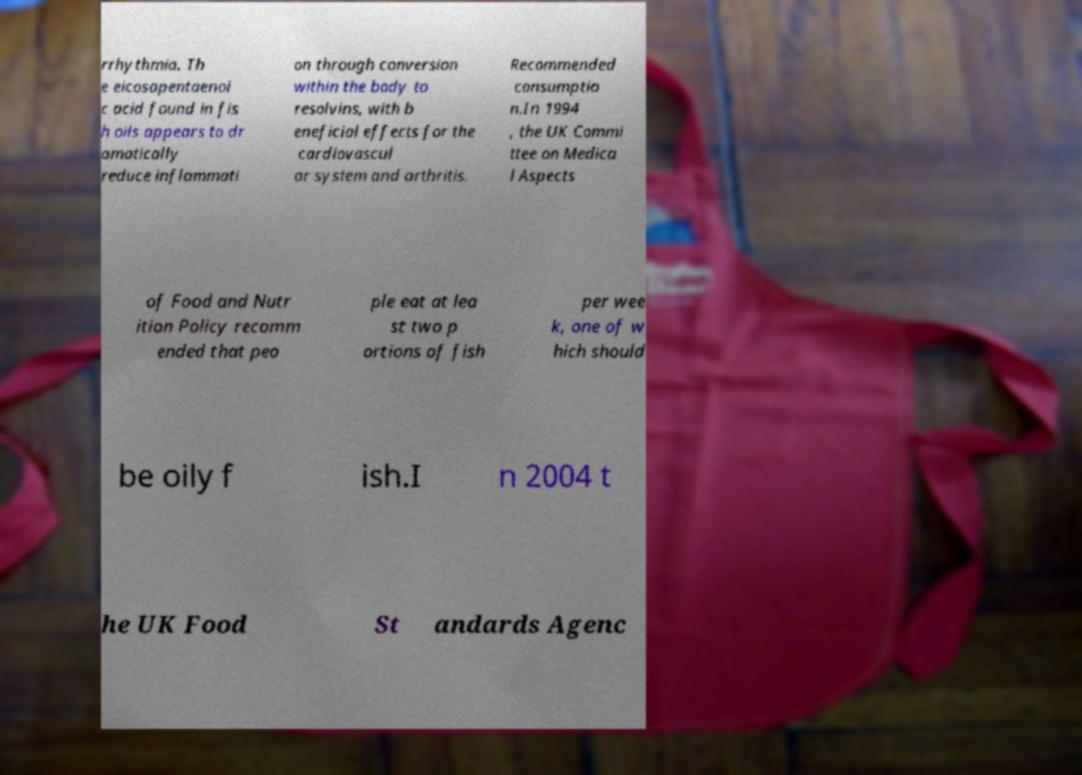What messages or text are displayed in this image? I need them in a readable, typed format. rrhythmia. Th e eicosapentaenoi c acid found in fis h oils appears to dr amatically reduce inflammati on through conversion within the body to resolvins, with b eneficial effects for the cardiovascul ar system and arthritis. Recommended consumptio n.In 1994 , the UK Commi ttee on Medica l Aspects of Food and Nutr ition Policy recomm ended that peo ple eat at lea st two p ortions of fish per wee k, one of w hich should be oily f ish.I n 2004 t he UK Food St andards Agenc 